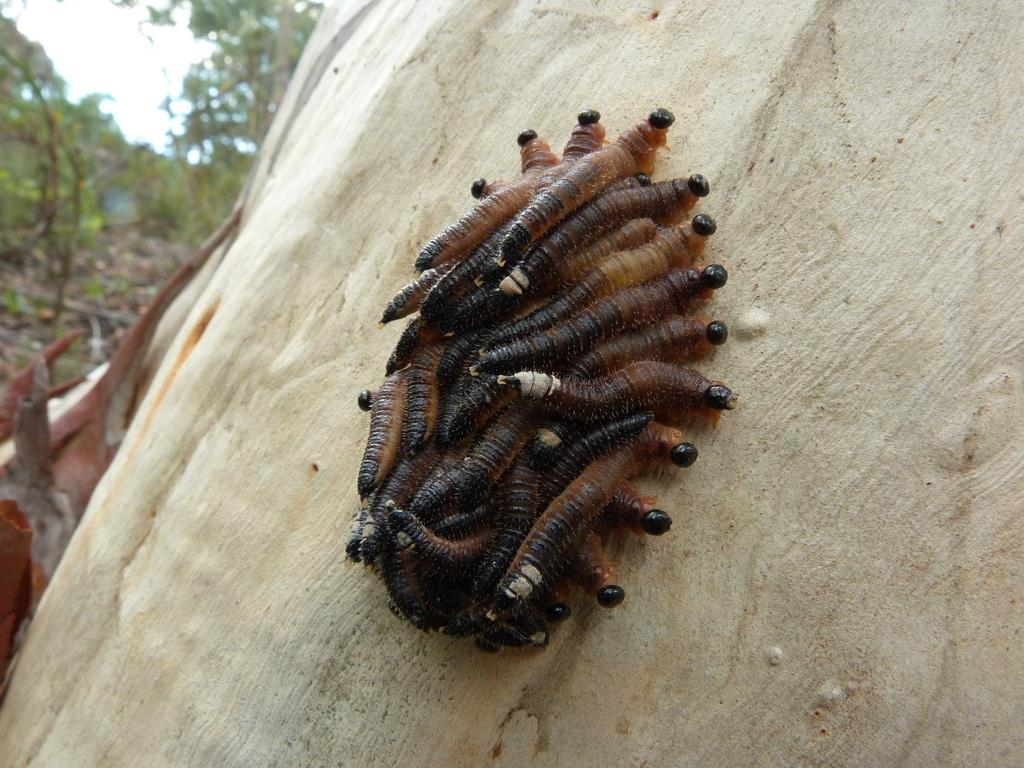What type of creatures are on the white surface in the image? There are worms on a white surface in the image. What can be seen in the background of the image? There are trees in the background of the worms are using to eat or move in the image? What is the color of the object in the center of the image? There is a brown object in the center of the image. What type of soup is being served in the image? There is no soup present in the image; it features worms on a white surface with trees in the background and a brown object in the center. 